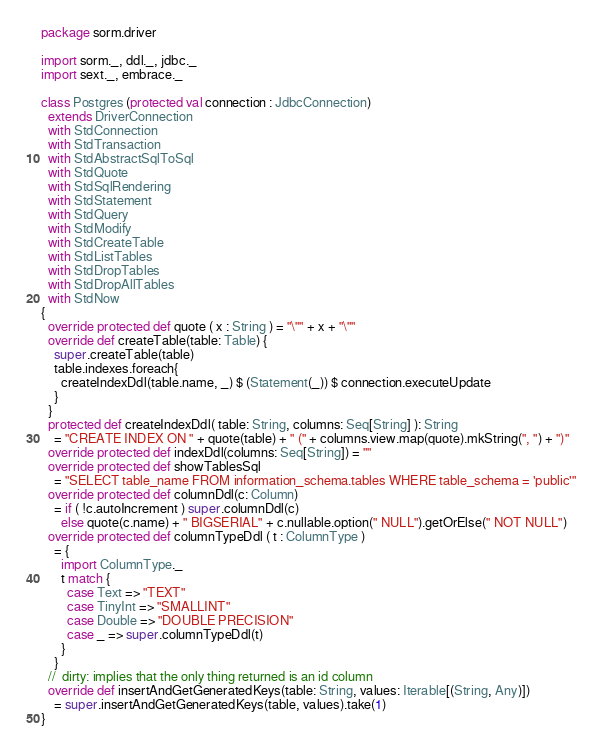<code> <loc_0><loc_0><loc_500><loc_500><_Scala_>package sorm.driver

import sorm._, ddl._, jdbc._
import sext._, embrace._

class Postgres (protected val connection : JdbcConnection)
  extends DriverConnection
  with StdConnection
  with StdTransaction
  with StdAbstractSqlToSql
  with StdQuote
  with StdSqlRendering
  with StdStatement
  with StdQuery
  with StdModify
  with StdCreateTable
  with StdListTables
  with StdDropTables
  with StdDropAllTables
  with StdNow
{
  override protected def quote ( x : String ) = "\"" + x + "\""
  override def createTable(table: Table) {
    super.createTable(table)
    table.indexes.foreach{
      createIndexDdl(table.name, _) $ (Statement(_)) $ connection.executeUpdate
    }
  }
  protected def createIndexDdl( table: String, columns: Seq[String] ): String
    = "CREATE INDEX ON " + quote(table) + " (" + columns.view.map(quote).mkString(", ") + ")"
  override protected def indexDdl(columns: Seq[String]) = ""
  override protected def showTablesSql
    = "SELECT table_name FROM information_schema.tables WHERE table_schema = 'public'"
  override protected def columnDdl(c: Column)
    = if ( !c.autoIncrement ) super.columnDdl(c)
      else quote(c.name) + " BIGSERIAL" + c.nullable.option(" NULL").getOrElse(" NOT NULL")
  override protected def columnTypeDdl ( t : ColumnType )
    = {
      import ColumnType._
      t match {
        case Text => "TEXT"
        case TinyInt => "SMALLINT"
        case Double => "DOUBLE PRECISION"
        case _ => super.columnTypeDdl(t)
      }
    }
  //  dirty: implies that the only thing returned is an id column
  override def insertAndGetGeneratedKeys(table: String, values: Iterable[(String, Any)])
    = super.insertAndGetGeneratedKeys(table, values).take(1)
}</code> 